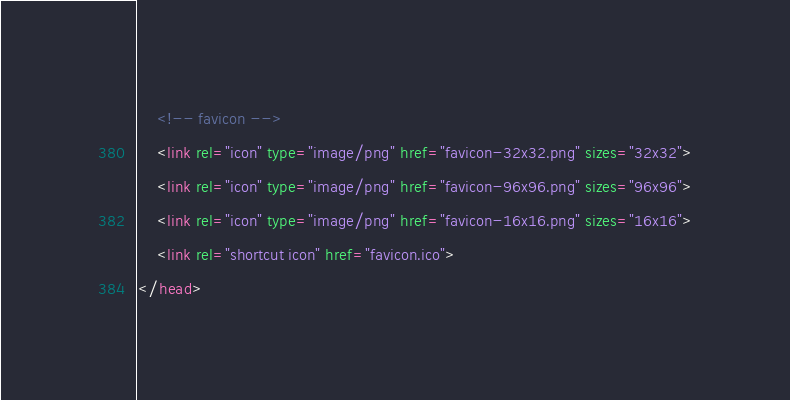<code> <loc_0><loc_0><loc_500><loc_500><_HTML_>    <!-- favicon -->
    <link rel="icon" type="image/png" href="favicon-32x32.png" sizes="32x32">
    <link rel="icon" type="image/png" href="favicon-96x96.png" sizes="96x96">
    <link rel="icon" type="image/png" href="favicon-16x16.png" sizes="16x16">
    <link rel="shortcut icon" href="favicon.ico">
</head>
</code> 